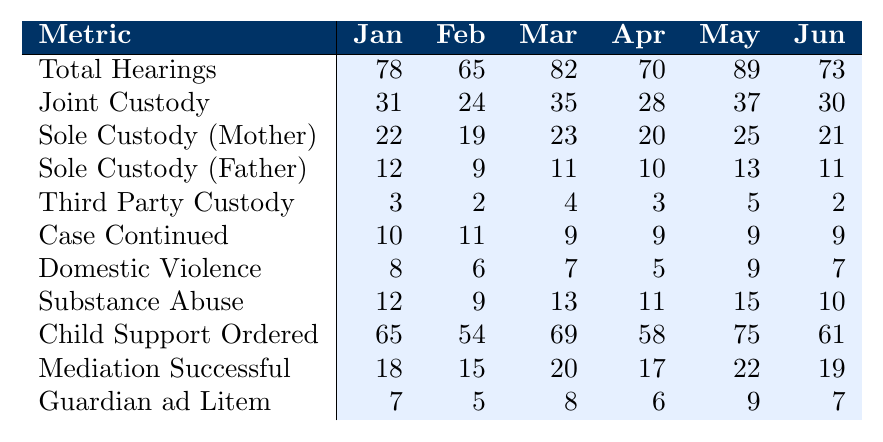What was the total number of child custody hearings in March? In the table, the total number of hearings for March is listed under the "Total Hearings" row for that month. The value shown is 82.
Answer: 82 How many joint custody orders were awarded in April? The value for joint custody awarded in April is found in the "Joint Custody" row for that month. It is 28.
Answer: 28 Which month had the highest number of sole custody awards to mothers? Looking at the "Sole Custody (Mother)" row, May shows the highest number with a value of 25, as compared to the other months.
Answer: May What is the total number of cases continued from January to June? To find the total, sum the values in the "Case Continued" row: 10 + 11 + 9 + 9 + 9 + 9 = 57.
Answer: 57 What percentage of hearings in February awarded joint custody? In February, there were 65 total hearings, with 24 joint custody awards. Calculate the percentage as (24/65) * 100 = 36.92%.
Answer: 36.92% Was the number of hearings where domestic violence was involved greater than the cases continued in any month? Comparing the "Domestic Violence" row with the "Case Continued" row, the maximum domestic violence cases reported was 9 in February, which equals the cases continued for January, April, May, and June, but no month has domestic violence cases exceeding continued cases. Thus, the answer is false.
Answer: No How many total sole custody awards (both parents) were there in June? To calculate this, add the values in the "Sole Custody (Mother)" and "Sole Custody (Father)" rows for June: 21 (mother) + 11 (father) = 32.
Answer: 32 What was the average number of successful mediations from January to June? To find the average, sum the values in the "Mediation Successful" row: 18 + 15 + 20 + 17 + 22 + 19 = 111. Divide this by the number of months, 6: 111 / 6 = 18.5.
Answer: 18.5 Which month had the lowest incidence of substance abuse involved in hearings? The lowest number is found in the "Substance Abuse" row for February with the value of 9, which is lower than all other months' figures.
Answer: February In how many months did the number of child support orders exceed 60? The values in the "Child Support Ordered" row must be counted for values greater than 60: January (65), March (69), May (75), and June (61), totaling 4 months.
Answer: 4 